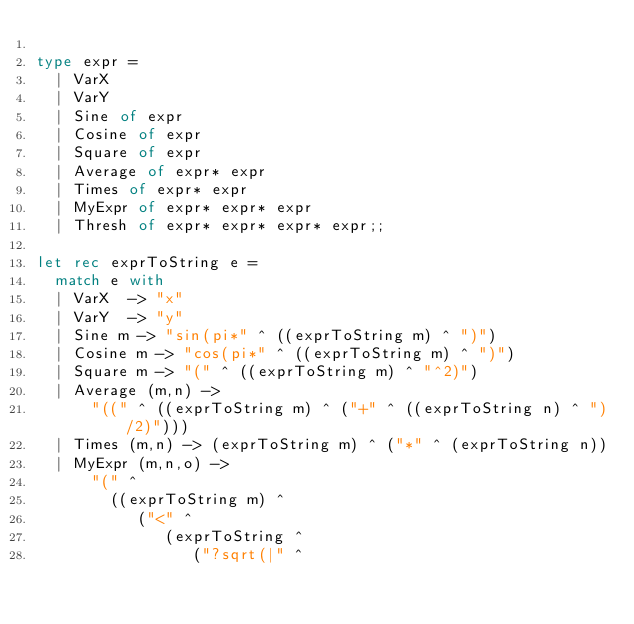<code> <loc_0><loc_0><loc_500><loc_500><_OCaml_>
type expr =
  | VarX
  | VarY
  | Sine of expr
  | Cosine of expr
  | Square of expr
  | Average of expr* expr
  | Times of expr* expr
  | MyExpr of expr* expr* expr
  | Thresh of expr* expr* expr* expr;;

let rec exprToString e =
  match e with
  | VarX  -> "x"
  | VarY  -> "y"
  | Sine m -> "sin(pi*" ^ ((exprToString m) ^ ")")
  | Cosine m -> "cos(pi*" ^ ((exprToString m) ^ ")")
  | Square m -> "(" ^ ((exprToString m) ^ "^2)")
  | Average (m,n) ->
      "((" ^ ((exprToString m) ^ ("+" ^ ((exprToString n) ^ ")/2)")))
  | Times (m,n) -> (exprToString m) ^ ("*" ^ (exprToString n))
  | MyExpr (m,n,o) ->
      "(" ^
        ((exprToString m) ^
           ("<" ^
              (exprToString ^
                 ("?sqrt(|" ^</code> 